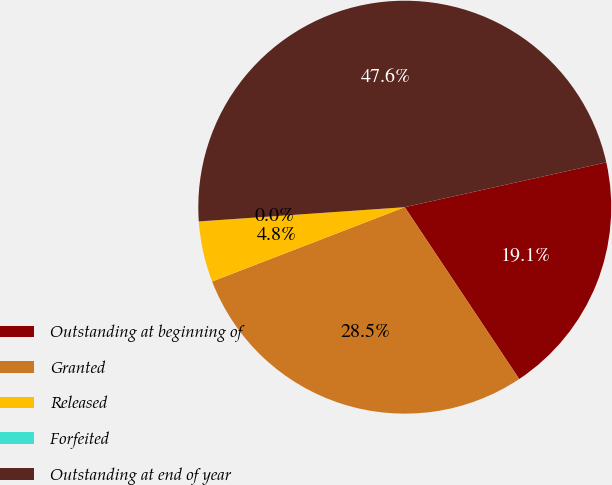<chart> <loc_0><loc_0><loc_500><loc_500><pie_chart><fcel>Outstanding at beginning of<fcel>Granted<fcel>Released<fcel>Forfeited<fcel>Outstanding at end of year<nl><fcel>19.13%<fcel>28.49%<fcel>4.76%<fcel>0.0%<fcel>47.62%<nl></chart> 